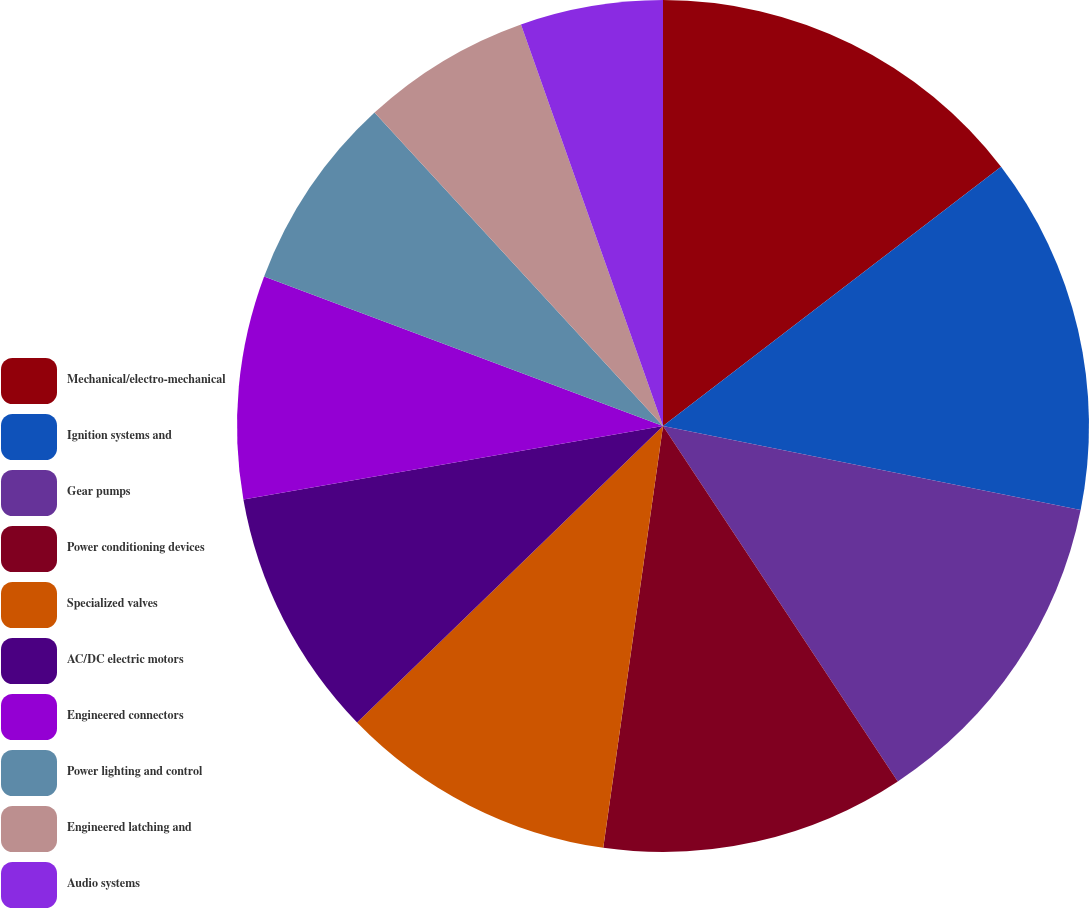Convert chart to OTSL. <chart><loc_0><loc_0><loc_500><loc_500><pie_chart><fcel>Mechanical/electro-mechanical<fcel>Ignition systems and<fcel>Gear pumps<fcel>Power conditioning devices<fcel>Specialized valves<fcel>AC/DC electric motors<fcel>Engineered connectors<fcel>Power lighting and control<fcel>Engineered latching and<fcel>Audio systems<nl><fcel>14.59%<fcel>13.57%<fcel>12.55%<fcel>11.53%<fcel>10.51%<fcel>9.49%<fcel>8.47%<fcel>7.45%<fcel>6.43%<fcel>5.41%<nl></chart> 